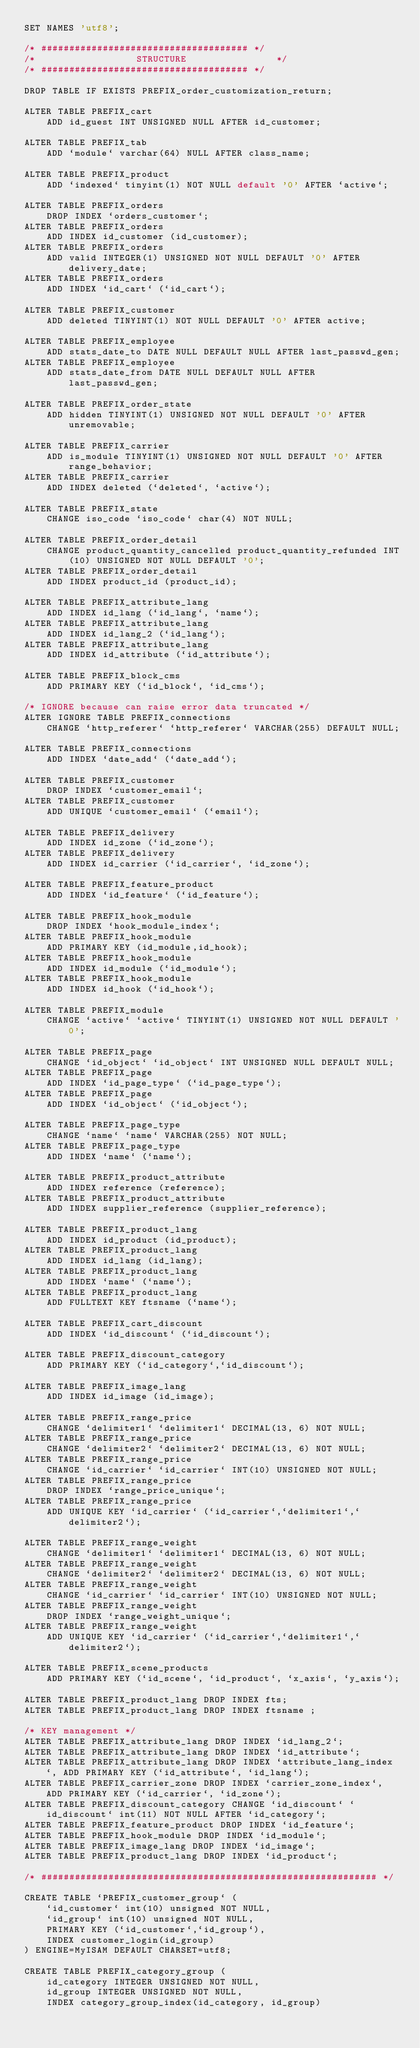Convert code to text. <code><loc_0><loc_0><loc_500><loc_500><_SQL_>SET NAMES 'utf8';

/* ##################################### */
/* 					STRUCTURE				 */
/* ##################################### */

DROP TABLE IF EXISTS PREFIX_order_customization_return;

ALTER TABLE PREFIX_cart
	ADD id_guest INT UNSIGNED NULL AFTER id_customer; 

ALTER TABLE PREFIX_tab
	ADD `module` varchar(64) NULL AFTER class_name;

ALTER TABLE PREFIX_product
	ADD `indexed` tinyint(1) NOT NULL default '0' AFTER `active`;
	
ALTER TABLE PREFIX_orders
	DROP INDEX `orders_customer`;
ALTER TABLE PREFIX_orders
	ADD INDEX id_customer (id_customer);
ALTER TABLE PREFIX_orders
	ADD valid INTEGER(1) UNSIGNED NOT NULL DEFAULT '0' AFTER delivery_date;
ALTER TABLE PREFIX_orders
	ADD INDEX `id_cart` (`id_cart`);

ALTER TABLE PREFIX_customer
	ADD deleted TINYINT(1) NOT NULL DEFAULT '0' AFTER active;

ALTER TABLE PREFIX_employee
	ADD stats_date_to DATE NULL DEFAULT NULL AFTER last_passwd_gen;
ALTER TABLE PREFIX_employee
	ADD stats_date_from DATE NULL DEFAULT NULL AFTER last_passwd_gen;

ALTER TABLE PREFIX_order_state
	ADD hidden TINYINT(1) UNSIGNED NOT NULL DEFAULT '0' AFTER unremovable;

ALTER TABLE PREFIX_carrier
	ADD is_module TINYINT(1) UNSIGNED NOT NULL DEFAULT '0' AFTER range_behavior;
ALTER TABLE PREFIX_carrier
	ADD INDEX deleted (`deleted`, `active`);

ALTER TABLE PREFIX_state
	CHANGE iso_code `iso_code` char(4) NOT NULL;
	
ALTER TABLE PREFIX_order_detail
	CHANGE product_quantity_cancelled product_quantity_refunded INT(10) UNSIGNED NOT NULL DEFAULT '0';
ALTER TABLE PREFIX_order_detail
	ADD INDEX product_id (product_id);

ALTER TABLE PREFIX_attribute_lang
	ADD INDEX id_lang (`id_lang`, `name`);
ALTER TABLE PREFIX_attribute_lang
	ADD INDEX id_lang_2 (`id_lang`);
ALTER TABLE PREFIX_attribute_lang
	ADD INDEX id_attribute (`id_attribute`);

ALTER TABLE PREFIX_block_cms
	ADD PRIMARY KEY (`id_block`, `id_cms`);

/* IGNORE because can raise error data truncated */
ALTER IGNORE TABLE PREFIX_connections
	CHANGE `http_referer` `http_referer` VARCHAR(255) DEFAULT NULL;
	
ALTER TABLE PREFIX_connections
	ADD INDEX `date_add` (`date_add`);

ALTER TABLE PREFIX_customer
	DROP INDEX `customer_email`;
ALTER TABLE PREFIX_customer
	ADD UNIQUE `customer_email` (`email`);

ALTER TABLE PREFIX_delivery
	ADD INDEX id_zone (`id_zone`);
ALTER TABLE PREFIX_delivery
	ADD INDEX id_carrier (`id_carrier`, `id_zone`);

ALTER TABLE PREFIX_feature_product
	ADD INDEX `id_feature` (`id_feature`);

ALTER TABLE PREFIX_hook_module
	DROP INDEX `hook_module_index`;
ALTER TABLE PREFIX_hook_module
	ADD PRIMARY KEY (id_module,id_hook);
ALTER TABLE PREFIX_hook_module
	ADD INDEX id_module (`id_module`);
ALTER TABLE PREFIX_hook_module
	ADD INDEX id_hook (`id_hook`);

ALTER TABLE PREFIX_module
	CHANGE `active` `active` TINYINT(1) UNSIGNED NOT NULL DEFAULT '0';

ALTER TABLE PREFIX_page
	CHANGE `id_object` `id_object` INT UNSIGNED NULL DEFAULT NULL;
ALTER TABLE PREFIX_page
	ADD INDEX `id_page_type` (`id_page_type`);
ALTER TABLE PREFIX_page
	ADD INDEX `id_object` (`id_object`);

ALTER TABLE PREFIX_page_type
	CHANGE `name` `name` VARCHAR(255) NOT NULL;
ALTER TABLE PREFIX_page_type
	ADD INDEX `name` (`name`);
	
ALTER TABLE PREFIX_product_attribute
	ADD INDEX reference (reference);
ALTER TABLE PREFIX_product_attribute
	ADD INDEX supplier_reference (supplier_reference);

ALTER TABLE PREFIX_product_lang
	ADD INDEX id_product (id_product);
ALTER TABLE PREFIX_product_lang
	ADD INDEX id_lang (id_lang);
ALTER TABLE PREFIX_product_lang
	ADD INDEX `name` (`name`);
ALTER TABLE PREFIX_product_lang
	ADD FULLTEXT KEY ftsname (`name`);
	
ALTER TABLE PREFIX_cart_discount
	ADD INDEX `id_discount` (`id_discount`);

ALTER TABLE PREFIX_discount_category
	ADD PRIMARY KEY (`id_category`,`id_discount`);

ALTER TABLE PREFIX_image_lang
	ADD INDEX id_image (id_image);

ALTER TABLE PREFIX_range_price
	CHANGE `delimiter1` `delimiter1` DECIMAL(13, 6) NOT NULL;
ALTER TABLE PREFIX_range_price
	CHANGE `delimiter2` `delimiter2` DECIMAL(13, 6) NOT NULL;
ALTER TABLE PREFIX_range_price
	CHANGE `id_carrier` `id_carrier` INT(10) UNSIGNED NOT NULL;
ALTER TABLE PREFIX_range_price
	DROP INDEX `range_price_unique`;
ALTER TABLE PREFIX_range_price
	ADD UNIQUE KEY `id_carrier` (`id_carrier`,`delimiter1`,`delimiter2`);

ALTER TABLE PREFIX_range_weight
	CHANGE `delimiter1` `delimiter1` DECIMAL(13, 6) NOT NULL;
ALTER TABLE PREFIX_range_weight
	CHANGE `delimiter2` `delimiter2` DECIMAL(13, 6) NOT NULL;
ALTER TABLE PREFIX_range_weight
	CHANGE `id_carrier` `id_carrier` INT(10) UNSIGNED NOT NULL;
ALTER TABLE PREFIX_range_weight
	DROP INDEX `range_weight_unique`;
ALTER TABLE PREFIX_range_weight
	ADD UNIQUE KEY `id_carrier` (`id_carrier`,`delimiter1`,`delimiter2`);

ALTER TABLE PREFIX_scene_products
	ADD PRIMARY KEY (`id_scene`, `id_product`, `x_axis`, `y_axis`);
	
ALTER TABLE PREFIX_product_lang DROP INDEX fts; 
ALTER TABLE PREFIX_product_lang DROP INDEX ftsname ;

/* KEY management */
ALTER TABLE PREFIX_attribute_lang DROP INDEX `id_lang_2`;
ALTER TABLE PREFIX_attribute_lang DROP INDEX `id_attribute`;
ALTER TABLE PREFIX_attribute_lang DROP INDEX `attribute_lang_index`, ADD PRIMARY KEY (`id_attribute`, `id_lang`);
ALTER TABLE PREFIX_carrier_zone DROP INDEX `carrier_zone_index`, ADD PRIMARY KEY (`id_carrier`, `id_zone`);
ALTER TABLE PREFIX_discount_category CHANGE `id_discount` `id_discount` int(11) NOT NULL AFTER `id_category`;
ALTER TABLE PREFIX_feature_product DROP INDEX `id_feature`;
ALTER TABLE PREFIX_hook_module DROP INDEX `id_module`;
ALTER TABLE PREFIX_image_lang DROP INDEX `id_image`;
ALTER TABLE PREFIX_product_lang DROP INDEX `id_product`;

/* ############################################################ */

CREATE TABLE `PREFIX_customer_group` (
	`id_customer` int(10) unsigned NOT NULL,
	`id_group` int(10) unsigned NOT NULL,
	PRIMARY KEY (`id_customer`,`id_group`),
	INDEX customer_login(id_group)
) ENGINE=MyISAM DEFAULT CHARSET=utf8;

CREATE TABLE PREFIX_category_group (
	id_category INTEGER UNSIGNED NOT NULL,
	id_group INTEGER UNSIGNED NOT NULL,
	INDEX category_group_index(id_category, id_group)</code> 